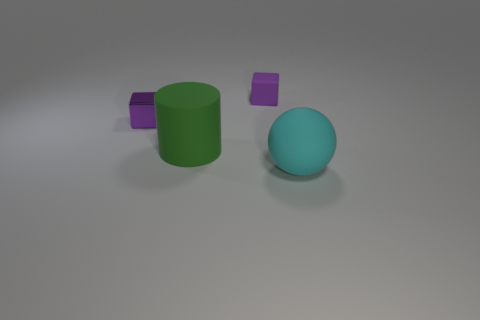Subtract 1 cylinders. How many cylinders are left? 0 Add 2 tiny purple shiny blocks. How many objects exist? 6 Subtract 1 green cylinders. How many objects are left? 3 Subtract all spheres. How many objects are left? 3 Subtract all gray balls. Subtract all purple cylinders. How many balls are left? 1 Subtract all red balls. How many gray cylinders are left? 0 Subtract all big rubber cylinders. Subtract all shiny cubes. How many objects are left? 2 Add 3 small matte cubes. How many small matte cubes are left? 4 Add 4 large brown matte blocks. How many large brown matte blocks exist? 4 